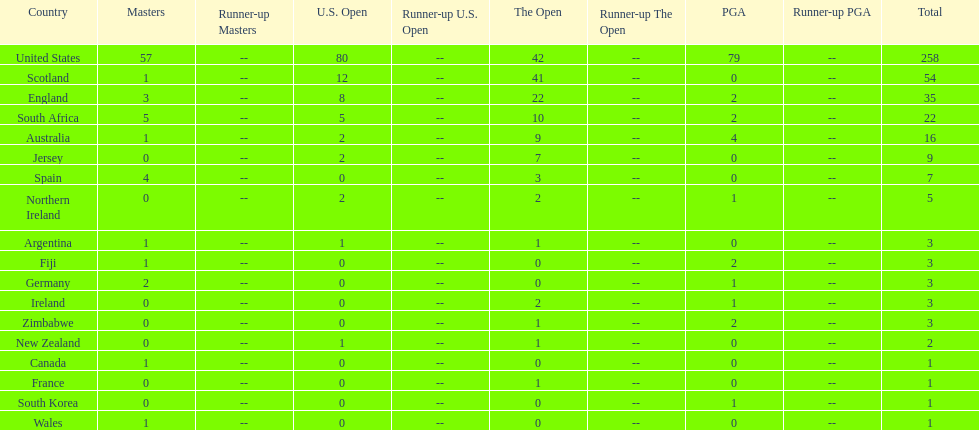Together, how many victorious golfers do england and wales have in the masters? 4. 